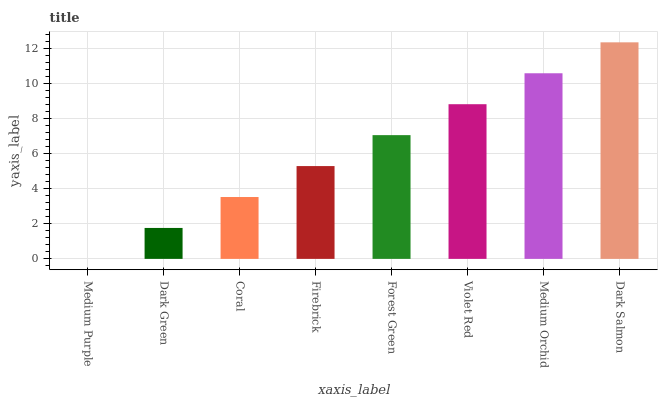Is Medium Purple the minimum?
Answer yes or no. Yes. Is Dark Salmon the maximum?
Answer yes or no. Yes. Is Dark Green the minimum?
Answer yes or no. No. Is Dark Green the maximum?
Answer yes or no. No. Is Dark Green greater than Medium Purple?
Answer yes or no. Yes. Is Medium Purple less than Dark Green?
Answer yes or no. Yes. Is Medium Purple greater than Dark Green?
Answer yes or no. No. Is Dark Green less than Medium Purple?
Answer yes or no. No. Is Forest Green the high median?
Answer yes or no. Yes. Is Firebrick the low median?
Answer yes or no. Yes. Is Medium Purple the high median?
Answer yes or no. No. Is Medium Orchid the low median?
Answer yes or no. No. 